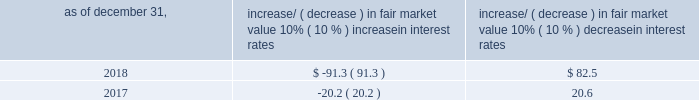Item 7a .
Quantitative and qualitative disclosures about market risk ( amounts in millions ) in the normal course of business , we are exposed to market risks related to interest rates , foreign currency rates and certain balance sheet items .
From time to time , we use derivative instruments , pursuant to established guidelines and policies , to manage some portion of these risks .
Derivative instruments utilized in our hedging activities are viewed as risk management tools and are not used for trading or speculative purposes .
Interest rates our exposure to market risk for changes in interest rates relates primarily to the fair market value and cash flows of our debt obligations .
The majority of our debt ( approximately 86% ( 86 % ) and 94% ( 94 % ) as of december 31 , 2018 and 2017 , respectively ) bears interest at fixed rates .
We do have debt with variable interest rates , but a 10% ( 10 % ) increase or decrease in interest rates would not be material to our interest expense or cash flows .
The fair market value of our debt is sensitive to changes in interest rates , and the impact of a 10% ( 10 % ) change in interest rates is summarized below .
Increase/ ( decrease ) in fair market value as of december 31 , 10% ( 10 % ) increase in interest rates 10% ( 10 % ) decrease in interest rates .
We have used interest rate swaps for risk management purposes to manage our exposure to changes in interest rates .
We did not have any interest rate swaps outstanding as of december 31 , 2018 .
We had $ 673.5 of cash , cash equivalents and marketable securities as of december 31 , 2018 that we generally invest in conservative , short-term bank deposits or securities .
The interest income generated from these investments is subject to both domestic and foreign interest rate movements .
During 2018 and 2017 , we had interest income of $ 21.8 and $ 19.4 , respectively .
Based on our 2018 results , a 100 basis-point increase or decrease in interest rates would affect our interest income by approximately $ 6.7 , assuming that all cash , cash equivalents and marketable securities are impacted in the same manner and balances remain constant from year-end 2018 levels .
Foreign currency rates we are subject to translation and transaction risks related to changes in foreign currency exchange rates .
Since we report revenues and expenses in u.s .
Dollars , changes in exchange rates may either positively or negatively affect our consolidated revenues and expenses ( as expressed in u.s .
Dollars ) from foreign operations .
The foreign currencies that most favorably impacted our results during the year ended december 31 , 2018 were the euro and british pound sterling .
The foreign currencies that most adversely impacted our results during the year ended december 31 , of 2018 were the argentine peso and brazilian real .
Based on 2018 exchange rates and operating results , if the u.s .
Dollar were to strengthen or weaken by 10% ( 10 % ) , we currently estimate operating income would decrease or increase approximately 4% ( 4 % ) , assuming that all currencies are impacted in the same manner and our international revenue and expenses remain constant at 2018 levels .
The functional currency of our foreign operations is generally their respective local currency .
Assets and liabilities are translated at the exchange rates in effect at the balance sheet date , and revenues and expenses are translated at the average exchange rates during the period presented .
The resulting translation adjustments are recorded as a component of accumulated other comprehensive loss , net of tax , in the stockholders 2019 equity section of our consolidated balance sheets .
Our foreign subsidiaries generally collect revenues and pay expenses in their functional currency , mitigating transaction risk .
However , certain subsidiaries may enter into transactions in currencies other than their functional currency .
Assets and liabilities denominated in currencies other than the functional currency are susceptible to movements in foreign currency until final settlement .
Currency transaction gains or losses primarily arising from transactions in currencies other than the functional currency are included in office and general expenses .
We regularly review our foreign exchange exposures that may have a material impact on our business and from time to time use foreign currency forward exchange contracts or other .
In 2018 what was the ratio of the impact to the fair market value of the 10% ( 10 % ) increase in interest rates to the 10% ( 10 % ) decrease in interest rates 3 2018? 
Computations: (-91.3 / 82.5)
Answer: -1.10667. 